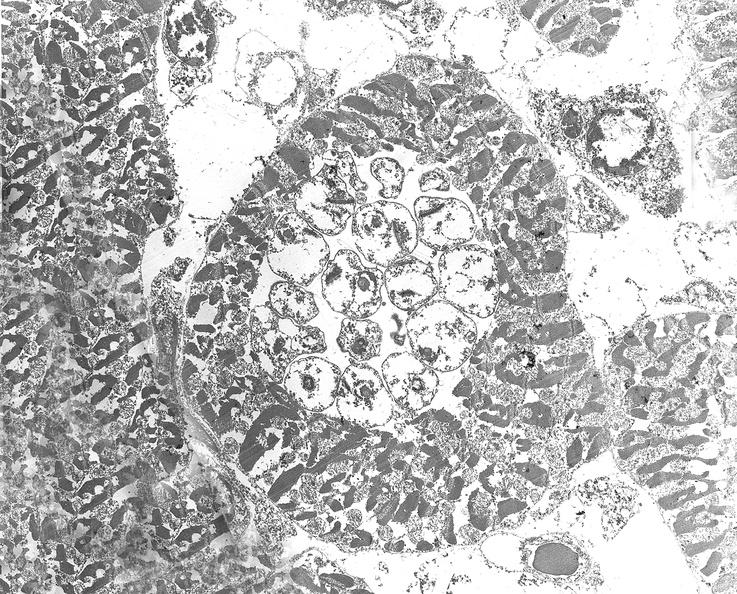what is present?
Answer the question using a single word or phrase. Cardiovascular 